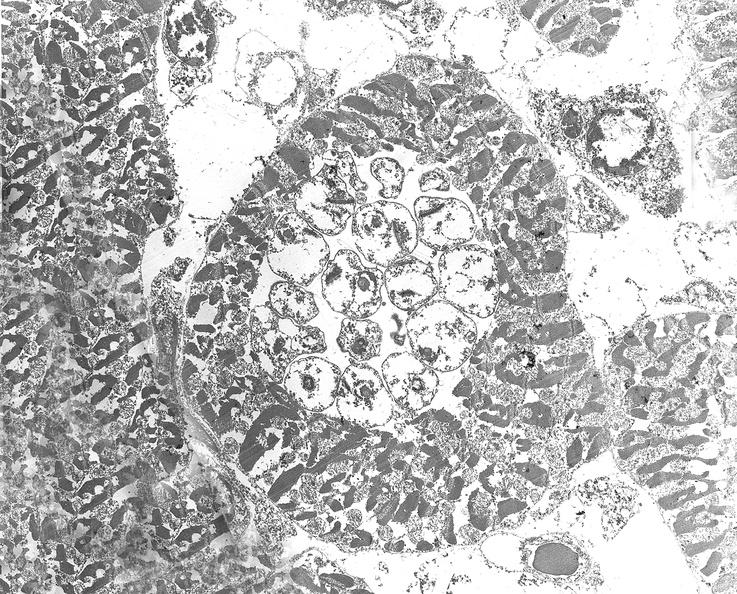what is present?
Answer the question using a single word or phrase. Cardiovascular 